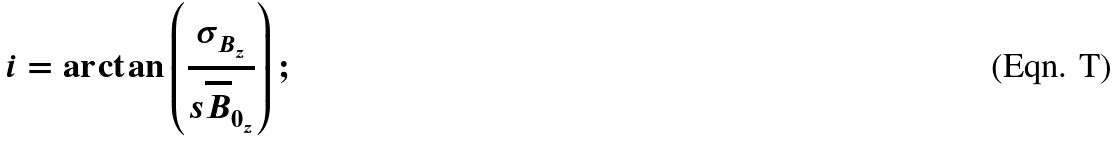Convert formula to latex. <formula><loc_0><loc_0><loc_500><loc_500>i = \arctan \left ( \frac { \sigma _ { B _ { z } } } { s \overline { B } _ { 0 _ { z } } } \right ) ;</formula> 